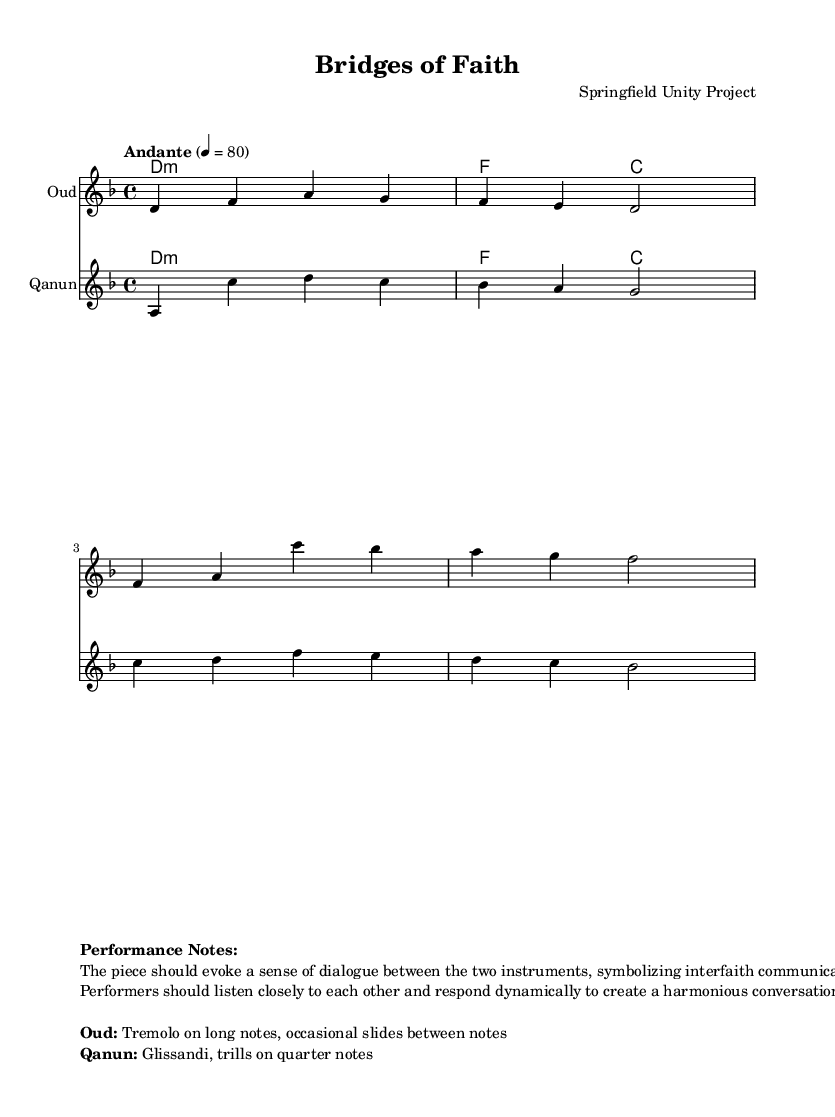What is the key signature of this music? The key signature is D minor, indicated by one flat (B flat) in the staff.
Answer: D minor What is the time signature of this music? The time signature is 4/4, shown as a '4' over another '4' at the beginning of the staff.
Answer: 4/4 What is the tempo marking of this piece? The tempo marking indicates "Andante" at a speed of 80 beats per minute, specifying how fast the piece should be played.
Answer: Andante 4 = 80 How many measures are in the oud part? The oud part contains four measures, as seen in the individual groupings of notes separated by bar lines.
Answer: Four What is the main purpose of the duet according to the performance notes? The main purpose of the duet is to evoke a sense of dialogue symbolizing interfaith communication, emphasizing collaboration between the instruments.
Answer: Dialogue What specific techniques are suggested for the oud? The performance notes suggest using tremolo on long notes and occasional slides between notes for the oud part, enhancing expressive play.
Answer: Tremolo and slides Which instrument is specified to have glissandi and trills? The qanun is specified to use glissandi and trills on quarter notes, as noted in the performance instructions for that instrument.
Answer: Qanun 